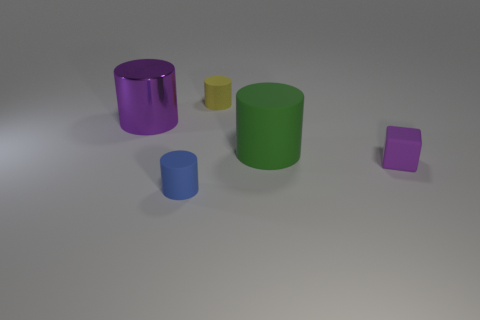Subtract all blue matte cylinders. How many cylinders are left? 3 Subtract all yellow cylinders. How many cylinders are left? 3 Subtract 1 cylinders. How many cylinders are left? 3 Add 5 purple cylinders. How many objects exist? 10 Subtract all red cylinders. Subtract all brown blocks. How many cylinders are left? 4 Subtract all blocks. How many objects are left? 4 Subtract 0 blue balls. How many objects are left? 5 Subtract all tiny brown matte blocks. Subtract all purple objects. How many objects are left? 3 Add 4 small yellow things. How many small yellow things are left? 5 Add 5 small red metallic balls. How many small red metallic balls exist? 5 